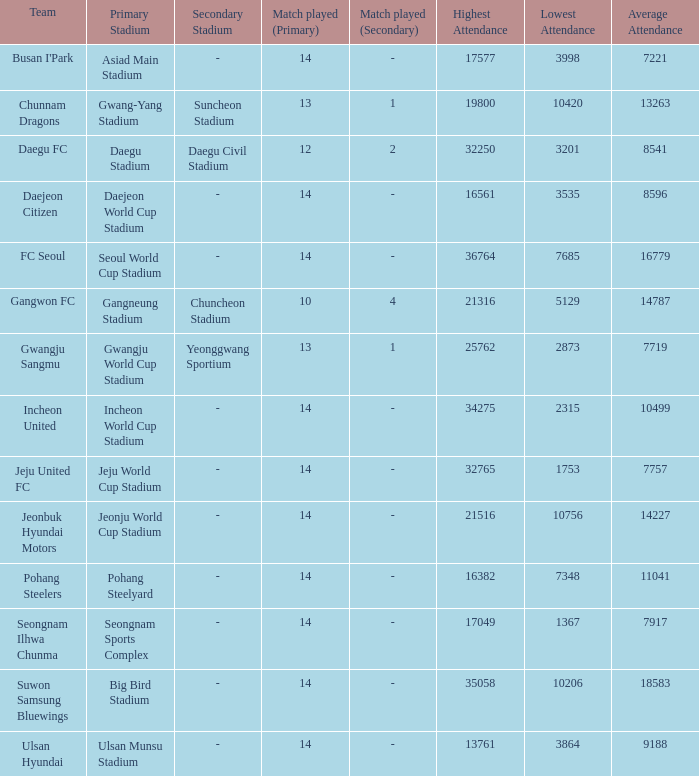Which team has 7757 as the average? Jeju United FC. 